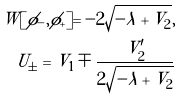<formula> <loc_0><loc_0><loc_500><loc_500>W [ \phi _ { - } , \phi _ { + } ] = - 2 \sqrt { - \lambda + V _ { 2 } } , \\ U _ { \pm } = V _ { 1 } \mp \frac { V ^ { \prime } _ { 2 } } { 2 \sqrt { - \lambda + V _ { 2 } } }</formula> 